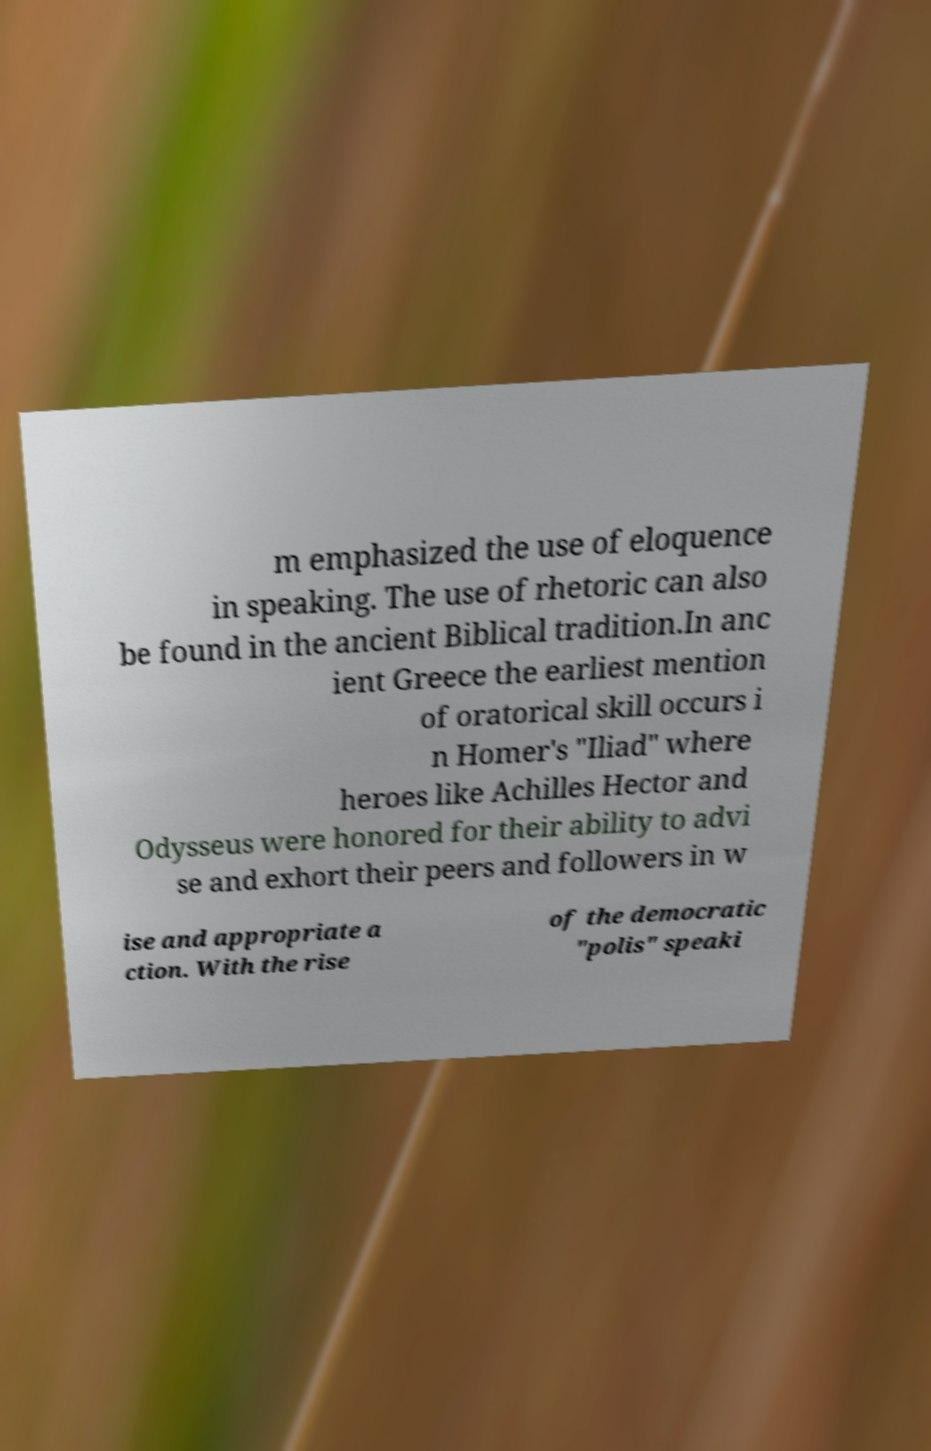Can you read and provide the text displayed in the image?This photo seems to have some interesting text. Can you extract and type it out for me? m emphasized the use of eloquence in speaking. The use of rhetoric can also be found in the ancient Biblical tradition.In anc ient Greece the earliest mention of oratorical skill occurs i n Homer's "Iliad" where heroes like Achilles Hector and Odysseus were honored for their ability to advi se and exhort their peers and followers in w ise and appropriate a ction. With the rise of the democratic "polis" speaki 